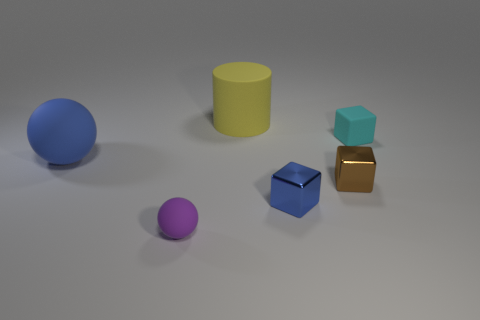Are there any other blocks that have the same material as the brown cube?
Provide a succinct answer. Yes. Is the size of the metal block that is on the left side of the brown object the same as the thing behind the small cyan block?
Give a very brief answer. No. What size is the object that is behind the tiny cyan object?
Make the answer very short. Large. Are there any tiny cubes that have the same color as the big matte ball?
Give a very brief answer. Yes. There is a rubber sphere behind the tiny blue object; are there any rubber balls that are in front of it?
Provide a succinct answer. Yes. There is a brown object; is it the same size as the blue object that is on the left side of the yellow object?
Provide a short and direct response. No. There is a yellow rubber thing behind the large rubber thing left of the yellow matte cylinder; are there any tiny blocks right of it?
Provide a succinct answer. Yes. What is the brown object in front of the large blue rubber thing made of?
Your answer should be very brief. Metal. Is the blue metal block the same size as the purple rubber thing?
Offer a terse response. Yes. There is a object that is to the left of the big yellow matte object and in front of the big sphere; what is its color?
Provide a succinct answer. Purple. 